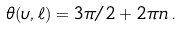<formula> <loc_0><loc_0><loc_500><loc_500>\theta ( \upsilon , \ell ) = 3 \pi / 2 + 2 \pi n \, .</formula> 